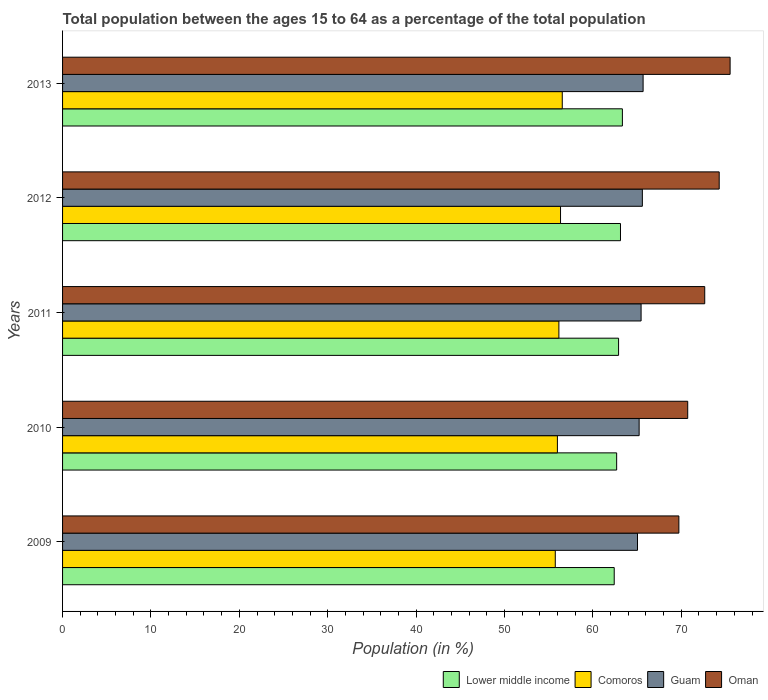How many groups of bars are there?
Your answer should be compact. 5. Are the number of bars per tick equal to the number of legend labels?
Your response must be concise. Yes. How many bars are there on the 3rd tick from the top?
Provide a succinct answer. 4. What is the label of the 1st group of bars from the top?
Provide a succinct answer. 2013. In how many cases, is the number of bars for a given year not equal to the number of legend labels?
Offer a terse response. 0. What is the percentage of the population ages 15 to 64 in Comoros in 2010?
Your answer should be very brief. 55.98. Across all years, what is the maximum percentage of the population ages 15 to 64 in Lower middle income?
Your answer should be compact. 63.34. Across all years, what is the minimum percentage of the population ages 15 to 64 in Lower middle income?
Ensure brevity in your answer.  62.41. In which year was the percentage of the population ages 15 to 64 in Comoros maximum?
Your answer should be compact. 2013. In which year was the percentage of the population ages 15 to 64 in Guam minimum?
Give a very brief answer. 2009. What is the total percentage of the population ages 15 to 64 in Comoros in the graph?
Offer a terse response. 280.75. What is the difference between the percentage of the population ages 15 to 64 in Oman in 2011 and that in 2013?
Your response must be concise. -2.87. What is the difference between the percentage of the population ages 15 to 64 in Guam in 2009 and the percentage of the population ages 15 to 64 in Comoros in 2012?
Give a very brief answer. 8.71. What is the average percentage of the population ages 15 to 64 in Guam per year?
Your answer should be very brief. 65.4. In the year 2011, what is the difference between the percentage of the population ages 15 to 64 in Comoros and percentage of the population ages 15 to 64 in Oman?
Make the answer very short. -16.5. In how many years, is the percentage of the population ages 15 to 64 in Comoros greater than 76 ?
Keep it short and to the point. 0. What is the ratio of the percentage of the population ages 15 to 64 in Oman in 2009 to that in 2013?
Your answer should be very brief. 0.92. Is the percentage of the population ages 15 to 64 in Guam in 2011 less than that in 2012?
Your answer should be very brief. Yes. Is the difference between the percentage of the population ages 15 to 64 in Comoros in 2010 and 2011 greater than the difference between the percentage of the population ages 15 to 64 in Oman in 2010 and 2011?
Make the answer very short. Yes. What is the difference between the highest and the second highest percentage of the population ages 15 to 64 in Guam?
Offer a terse response. 0.08. What is the difference between the highest and the lowest percentage of the population ages 15 to 64 in Oman?
Keep it short and to the point. 5.8. In how many years, is the percentage of the population ages 15 to 64 in Comoros greater than the average percentage of the population ages 15 to 64 in Comoros taken over all years?
Your answer should be compact. 3. Is it the case that in every year, the sum of the percentage of the population ages 15 to 64 in Comoros and percentage of the population ages 15 to 64 in Lower middle income is greater than the sum of percentage of the population ages 15 to 64 in Oman and percentage of the population ages 15 to 64 in Guam?
Your response must be concise. No. What does the 4th bar from the top in 2010 represents?
Your answer should be compact. Lower middle income. What does the 3rd bar from the bottom in 2010 represents?
Keep it short and to the point. Guam. Are the values on the major ticks of X-axis written in scientific E-notation?
Your response must be concise. No. Does the graph contain any zero values?
Your answer should be very brief. No. Where does the legend appear in the graph?
Your answer should be very brief. Bottom right. How are the legend labels stacked?
Offer a very short reply. Horizontal. What is the title of the graph?
Make the answer very short. Total population between the ages 15 to 64 as a percentage of the total population. What is the label or title of the Y-axis?
Provide a short and direct response. Years. What is the Population (in %) of Lower middle income in 2009?
Your answer should be compact. 62.41. What is the Population (in %) in Comoros in 2009?
Provide a short and direct response. 55.74. What is the Population (in %) in Guam in 2009?
Your answer should be compact. 65.05. What is the Population (in %) in Oman in 2009?
Provide a short and direct response. 69.73. What is the Population (in %) in Lower middle income in 2010?
Provide a short and direct response. 62.69. What is the Population (in %) of Comoros in 2010?
Ensure brevity in your answer.  55.98. What is the Population (in %) in Guam in 2010?
Provide a succinct answer. 65.23. What is the Population (in %) of Oman in 2010?
Ensure brevity in your answer.  70.73. What is the Population (in %) in Lower middle income in 2011?
Keep it short and to the point. 62.9. What is the Population (in %) of Comoros in 2011?
Offer a very short reply. 56.15. What is the Population (in %) of Guam in 2011?
Make the answer very short. 65.45. What is the Population (in %) in Oman in 2011?
Offer a terse response. 72.65. What is the Population (in %) of Lower middle income in 2012?
Provide a short and direct response. 63.12. What is the Population (in %) of Comoros in 2012?
Provide a succinct answer. 56.34. What is the Population (in %) in Guam in 2012?
Offer a very short reply. 65.6. What is the Population (in %) of Oman in 2012?
Provide a succinct answer. 74.29. What is the Population (in %) in Lower middle income in 2013?
Give a very brief answer. 63.34. What is the Population (in %) of Comoros in 2013?
Provide a short and direct response. 56.53. What is the Population (in %) in Guam in 2013?
Give a very brief answer. 65.68. What is the Population (in %) of Oman in 2013?
Make the answer very short. 75.52. Across all years, what is the maximum Population (in %) of Lower middle income?
Provide a succinct answer. 63.34. Across all years, what is the maximum Population (in %) in Comoros?
Ensure brevity in your answer.  56.53. Across all years, what is the maximum Population (in %) in Guam?
Give a very brief answer. 65.68. Across all years, what is the maximum Population (in %) in Oman?
Give a very brief answer. 75.52. Across all years, what is the minimum Population (in %) of Lower middle income?
Offer a terse response. 62.41. Across all years, what is the minimum Population (in %) in Comoros?
Keep it short and to the point. 55.74. Across all years, what is the minimum Population (in %) of Guam?
Offer a terse response. 65.05. Across all years, what is the minimum Population (in %) of Oman?
Offer a very short reply. 69.73. What is the total Population (in %) of Lower middle income in the graph?
Offer a very short reply. 314.46. What is the total Population (in %) in Comoros in the graph?
Your answer should be compact. 280.75. What is the total Population (in %) in Guam in the graph?
Your answer should be very brief. 327.01. What is the total Population (in %) of Oman in the graph?
Your answer should be compact. 362.92. What is the difference between the Population (in %) in Lower middle income in 2009 and that in 2010?
Your response must be concise. -0.28. What is the difference between the Population (in %) in Comoros in 2009 and that in 2010?
Offer a terse response. -0.24. What is the difference between the Population (in %) of Guam in 2009 and that in 2010?
Ensure brevity in your answer.  -0.19. What is the difference between the Population (in %) of Oman in 2009 and that in 2010?
Your response must be concise. -1. What is the difference between the Population (in %) in Lower middle income in 2009 and that in 2011?
Offer a very short reply. -0.49. What is the difference between the Population (in %) of Comoros in 2009 and that in 2011?
Ensure brevity in your answer.  -0.41. What is the difference between the Population (in %) of Guam in 2009 and that in 2011?
Make the answer very short. -0.41. What is the difference between the Population (in %) in Oman in 2009 and that in 2011?
Ensure brevity in your answer.  -2.93. What is the difference between the Population (in %) of Lower middle income in 2009 and that in 2012?
Make the answer very short. -0.71. What is the difference between the Population (in %) in Comoros in 2009 and that in 2012?
Your answer should be compact. -0.59. What is the difference between the Population (in %) in Guam in 2009 and that in 2012?
Your response must be concise. -0.55. What is the difference between the Population (in %) in Oman in 2009 and that in 2012?
Your answer should be very brief. -4.56. What is the difference between the Population (in %) of Lower middle income in 2009 and that in 2013?
Make the answer very short. -0.92. What is the difference between the Population (in %) in Comoros in 2009 and that in 2013?
Make the answer very short. -0.79. What is the difference between the Population (in %) of Guam in 2009 and that in 2013?
Ensure brevity in your answer.  -0.63. What is the difference between the Population (in %) of Oman in 2009 and that in 2013?
Your answer should be compact. -5.8. What is the difference between the Population (in %) in Lower middle income in 2010 and that in 2011?
Make the answer very short. -0.22. What is the difference between the Population (in %) in Comoros in 2010 and that in 2011?
Provide a short and direct response. -0.17. What is the difference between the Population (in %) in Guam in 2010 and that in 2011?
Offer a very short reply. -0.22. What is the difference between the Population (in %) of Oman in 2010 and that in 2011?
Ensure brevity in your answer.  -1.93. What is the difference between the Population (in %) in Lower middle income in 2010 and that in 2012?
Ensure brevity in your answer.  -0.43. What is the difference between the Population (in %) of Comoros in 2010 and that in 2012?
Offer a terse response. -0.35. What is the difference between the Population (in %) of Guam in 2010 and that in 2012?
Offer a very short reply. -0.36. What is the difference between the Population (in %) of Oman in 2010 and that in 2012?
Your answer should be compact. -3.56. What is the difference between the Population (in %) in Lower middle income in 2010 and that in 2013?
Keep it short and to the point. -0.65. What is the difference between the Population (in %) in Comoros in 2010 and that in 2013?
Give a very brief answer. -0.55. What is the difference between the Population (in %) of Guam in 2010 and that in 2013?
Keep it short and to the point. -0.45. What is the difference between the Population (in %) of Oman in 2010 and that in 2013?
Your answer should be very brief. -4.8. What is the difference between the Population (in %) of Lower middle income in 2011 and that in 2012?
Keep it short and to the point. -0.22. What is the difference between the Population (in %) of Comoros in 2011 and that in 2012?
Offer a very short reply. -0.19. What is the difference between the Population (in %) of Guam in 2011 and that in 2012?
Make the answer very short. -0.14. What is the difference between the Population (in %) of Oman in 2011 and that in 2012?
Your response must be concise. -1.64. What is the difference between the Population (in %) in Lower middle income in 2011 and that in 2013?
Provide a succinct answer. -0.43. What is the difference between the Population (in %) of Comoros in 2011 and that in 2013?
Keep it short and to the point. -0.38. What is the difference between the Population (in %) in Guam in 2011 and that in 2013?
Provide a short and direct response. -0.23. What is the difference between the Population (in %) of Oman in 2011 and that in 2013?
Your answer should be compact. -2.87. What is the difference between the Population (in %) of Lower middle income in 2012 and that in 2013?
Give a very brief answer. -0.21. What is the difference between the Population (in %) in Comoros in 2012 and that in 2013?
Your answer should be very brief. -0.2. What is the difference between the Population (in %) in Guam in 2012 and that in 2013?
Your answer should be compact. -0.08. What is the difference between the Population (in %) of Oman in 2012 and that in 2013?
Offer a very short reply. -1.23. What is the difference between the Population (in %) in Lower middle income in 2009 and the Population (in %) in Comoros in 2010?
Offer a very short reply. 6.43. What is the difference between the Population (in %) of Lower middle income in 2009 and the Population (in %) of Guam in 2010?
Ensure brevity in your answer.  -2.82. What is the difference between the Population (in %) of Lower middle income in 2009 and the Population (in %) of Oman in 2010?
Provide a short and direct response. -8.31. What is the difference between the Population (in %) in Comoros in 2009 and the Population (in %) in Guam in 2010?
Provide a succinct answer. -9.49. What is the difference between the Population (in %) in Comoros in 2009 and the Population (in %) in Oman in 2010?
Your answer should be very brief. -14.98. What is the difference between the Population (in %) of Guam in 2009 and the Population (in %) of Oman in 2010?
Your response must be concise. -5.68. What is the difference between the Population (in %) in Lower middle income in 2009 and the Population (in %) in Comoros in 2011?
Make the answer very short. 6.26. What is the difference between the Population (in %) in Lower middle income in 2009 and the Population (in %) in Guam in 2011?
Provide a short and direct response. -3.04. What is the difference between the Population (in %) in Lower middle income in 2009 and the Population (in %) in Oman in 2011?
Provide a succinct answer. -10.24. What is the difference between the Population (in %) in Comoros in 2009 and the Population (in %) in Guam in 2011?
Your answer should be very brief. -9.71. What is the difference between the Population (in %) in Comoros in 2009 and the Population (in %) in Oman in 2011?
Make the answer very short. -16.91. What is the difference between the Population (in %) of Guam in 2009 and the Population (in %) of Oman in 2011?
Ensure brevity in your answer.  -7.61. What is the difference between the Population (in %) of Lower middle income in 2009 and the Population (in %) of Comoros in 2012?
Offer a terse response. 6.07. What is the difference between the Population (in %) in Lower middle income in 2009 and the Population (in %) in Guam in 2012?
Ensure brevity in your answer.  -3.18. What is the difference between the Population (in %) in Lower middle income in 2009 and the Population (in %) in Oman in 2012?
Keep it short and to the point. -11.88. What is the difference between the Population (in %) of Comoros in 2009 and the Population (in %) of Guam in 2012?
Provide a succinct answer. -9.85. What is the difference between the Population (in %) of Comoros in 2009 and the Population (in %) of Oman in 2012?
Your response must be concise. -18.54. What is the difference between the Population (in %) in Guam in 2009 and the Population (in %) in Oman in 2012?
Your response must be concise. -9.24. What is the difference between the Population (in %) in Lower middle income in 2009 and the Population (in %) in Comoros in 2013?
Your answer should be very brief. 5.88. What is the difference between the Population (in %) in Lower middle income in 2009 and the Population (in %) in Guam in 2013?
Make the answer very short. -3.27. What is the difference between the Population (in %) of Lower middle income in 2009 and the Population (in %) of Oman in 2013?
Your answer should be very brief. -13.11. What is the difference between the Population (in %) of Comoros in 2009 and the Population (in %) of Guam in 2013?
Your answer should be very brief. -9.94. What is the difference between the Population (in %) of Comoros in 2009 and the Population (in %) of Oman in 2013?
Offer a terse response. -19.78. What is the difference between the Population (in %) of Guam in 2009 and the Population (in %) of Oman in 2013?
Give a very brief answer. -10.48. What is the difference between the Population (in %) in Lower middle income in 2010 and the Population (in %) in Comoros in 2011?
Keep it short and to the point. 6.54. What is the difference between the Population (in %) of Lower middle income in 2010 and the Population (in %) of Guam in 2011?
Give a very brief answer. -2.76. What is the difference between the Population (in %) of Lower middle income in 2010 and the Population (in %) of Oman in 2011?
Give a very brief answer. -9.96. What is the difference between the Population (in %) in Comoros in 2010 and the Population (in %) in Guam in 2011?
Your answer should be compact. -9.47. What is the difference between the Population (in %) of Comoros in 2010 and the Population (in %) of Oman in 2011?
Your answer should be compact. -16.67. What is the difference between the Population (in %) of Guam in 2010 and the Population (in %) of Oman in 2011?
Offer a terse response. -7.42. What is the difference between the Population (in %) of Lower middle income in 2010 and the Population (in %) of Comoros in 2012?
Your response must be concise. 6.35. What is the difference between the Population (in %) in Lower middle income in 2010 and the Population (in %) in Guam in 2012?
Your answer should be very brief. -2.91. What is the difference between the Population (in %) of Lower middle income in 2010 and the Population (in %) of Oman in 2012?
Provide a succinct answer. -11.6. What is the difference between the Population (in %) in Comoros in 2010 and the Population (in %) in Guam in 2012?
Offer a very short reply. -9.61. What is the difference between the Population (in %) of Comoros in 2010 and the Population (in %) of Oman in 2012?
Make the answer very short. -18.31. What is the difference between the Population (in %) in Guam in 2010 and the Population (in %) in Oman in 2012?
Your answer should be compact. -9.06. What is the difference between the Population (in %) of Lower middle income in 2010 and the Population (in %) of Comoros in 2013?
Offer a terse response. 6.15. What is the difference between the Population (in %) in Lower middle income in 2010 and the Population (in %) in Guam in 2013?
Your answer should be very brief. -2.99. What is the difference between the Population (in %) of Lower middle income in 2010 and the Population (in %) of Oman in 2013?
Provide a succinct answer. -12.84. What is the difference between the Population (in %) in Comoros in 2010 and the Population (in %) in Guam in 2013?
Keep it short and to the point. -9.7. What is the difference between the Population (in %) in Comoros in 2010 and the Population (in %) in Oman in 2013?
Offer a terse response. -19.54. What is the difference between the Population (in %) of Guam in 2010 and the Population (in %) of Oman in 2013?
Your response must be concise. -10.29. What is the difference between the Population (in %) of Lower middle income in 2011 and the Population (in %) of Comoros in 2012?
Make the answer very short. 6.57. What is the difference between the Population (in %) of Lower middle income in 2011 and the Population (in %) of Guam in 2012?
Offer a very short reply. -2.69. What is the difference between the Population (in %) in Lower middle income in 2011 and the Population (in %) in Oman in 2012?
Offer a terse response. -11.38. What is the difference between the Population (in %) of Comoros in 2011 and the Population (in %) of Guam in 2012?
Offer a very short reply. -9.44. What is the difference between the Population (in %) in Comoros in 2011 and the Population (in %) in Oman in 2012?
Offer a very short reply. -18.14. What is the difference between the Population (in %) of Guam in 2011 and the Population (in %) of Oman in 2012?
Provide a succinct answer. -8.84. What is the difference between the Population (in %) in Lower middle income in 2011 and the Population (in %) in Comoros in 2013?
Your response must be concise. 6.37. What is the difference between the Population (in %) in Lower middle income in 2011 and the Population (in %) in Guam in 2013?
Make the answer very short. -2.78. What is the difference between the Population (in %) in Lower middle income in 2011 and the Population (in %) in Oman in 2013?
Your answer should be very brief. -12.62. What is the difference between the Population (in %) in Comoros in 2011 and the Population (in %) in Guam in 2013?
Offer a terse response. -9.53. What is the difference between the Population (in %) of Comoros in 2011 and the Population (in %) of Oman in 2013?
Offer a terse response. -19.37. What is the difference between the Population (in %) of Guam in 2011 and the Population (in %) of Oman in 2013?
Provide a short and direct response. -10.07. What is the difference between the Population (in %) of Lower middle income in 2012 and the Population (in %) of Comoros in 2013?
Offer a very short reply. 6.59. What is the difference between the Population (in %) in Lower middle income in 2012 and the Population (in %) in Guam in 2013?
Keep it short and to the point. -2.56. What is the difference between the Population (in %) in Lower middle income in 2012 and the Population (in %) in Oman in 2013?
Ensure brevity in your answer.  -12.4. What is the difference between the Population (in %) in Comoros in 2012 and the Population (in %) in Guam in 2013?
Make the answer very short. -9.34. What is the difference between the Population (in %) of Comoros in 2012 and the Population (in %) of Oman in 2013?
Make the answer very short. -19.19. What is the difference between the Population (in %) in Guam in 2012 and the Population (in %) in Oman in 2013?
Keep it short and to the point. -9.93. What is the average Population (in %) in Lower middle income per year?
Your response must be concise. 62.89. What is the average Population (in %) of Comoros per year?
Ensure brevity in your answer.  56.15. What is the average Population (in %) of Guam per year?
Offer a very short reply. 65.4. What is the average Population (in %) in Oman per year?
Provide a short and direct response. 72.58. In the year 2009, what is the difference between the Population (in %) of Lower middle income and Population (in %) of Comoros?
Your answer should be very brief. 6.67. In the year 2009, what is the difference between the Population (in %) of Lower middle income and Population (in %) of Guam?
Offer a very short reply. -2.63. In the year 2009, what is the difference between the Population (in %) in Lower middle income and Population (in %) in Oman?
Ensure brevity in your answer.  -7.31. In the year 2009, what is the difference between the Population (in %) of Comoros and Population (in %) of Guam?
Provide a short and direct response. -9.3. In the year 2009, what is the difference between the Population (in %) of Comoros and Population (in %) of Oman?
Keep it short and to the point. -13.98. In the year 2009, what is the difference between the Population (in %) in Guam and Population (in %) in Oman?
Keep it short and to the point. -4.68. In the year 2010, what is the difference between the Population (in %) in Lower middle income and Population (in %) in Comoros?
Ensure brevity in your answer.  6.7. In the year 2010, what is the difference between the Population (in %) of Lower middle income and Population (in %) of Guam?
Give a very brief answer. -2.54. In the year 2010, what is the difference between the Population (in %) of Lower middle income and Population (in %) of Oman?
Your response must be concise. -8.04. In the year 2010, what is the difference between the Population (in %) in Comoros and Population (in %) in Guam?
Make the answer very short. -9.25. In the year 2010, what is the difference between the Population (in %) in Comoros and Population (in %) in Oman?
Your answer should be compact. -14.74. In the year 2010, what is the difference between the Population (in %) in Guam and Population (in %) in Oman?
Make the answer very short. -5.5. In the year 2011, what is the difference between the Population (in %) of Lower middle income and Population (in %) of Comoros?
Offer a terse response. 6.75. In the year 2011, what is the difference between the Population (in %) of Lower middle income and Population (in %) of Guam?
Keep it short and to the point. -2.55. In the year 2011, what is the difference between the Population (in %) of Lower middle income and Population (in %) of Oman?
Keep it short and to the point. -9.75. In the year 2011, what is the difference between the Population (in %) in Comoros and Population (in %) in Guam?
Provide a short and direct response. -9.3. In the year 2011, what is the difference between the Population (in %) in Comoros and Population (in %) in Oman?
Ensure brevity in your answer.  -16.5. In the year 2011, what is the difference between the Population (in %) of Guam and Population (in %) of Oman?
Make the answer very short. -7.2. In the year 2012, what is the difference between the Population (in %) in Lower middle income and Population (in %) in Comoros?
Your response must be concise. 6.78. In the year 2012, what is the difference between the Population (in %) of Lower middle income and Population (in %) of Guam?
Provide a short and direct response. -2.47. In the year 2012, what is the difference between the Population (in %) of Lower middle income and Population (in %) of Oman?
Your answer should be compact. -11.17. In the year 2012, what is the difference between the Population (in %) of Comoros and Population (in %) of Guam?
Your response must be concise. -9.26. In the year 2012, what is the difference between the Population (in %) in Comoros and Population (in %) in Oman?
Provide a short and direct response. -17.95. In the year 2012, what is the difference between the Population (in %) of Guam and Population (in %) of Oman?
Keep it short and to the point. -8.69. In the year 2013, what is the difference between the Population (in %) in Lower middle income and Population (in %) in Comoros?
Offer a very short reply. 6.8. In the year 2013, what is the difference between the Population (in %) of Lower middle income and Population (in %) of Guam?
Your answer should be very brief. -2.35. In the year 2013, what is the difference between the Population (in %) in Lower middle income and Population (in %) in Oman?
Give a very brief answer. -12.19. In the year 2013, what is the difference between the Population (in %) of Comoros and Population (in %) of Guam?
Offer a very short reply. -9.15. In the year 2013, what is the difference between the Population (in %) of Comoros and Population (in %) of Oman?
Ensure brevity in your answer.  -18.99. In the year 2013, what is the difference between the Population (in %) of Guam and Population (in %) of Oman?
Offer a terse response. -9.84. What is the ratio of the Population (in %) of Lower middle income in 2009 to that in 2010?
Your response must be concise. 1. What is the ratio of the Population (in %) in Oman in 2009 to that in 2010?
Provide a succinct answer. 0.99. What is the ratio of the Population (in %) in Comoros in 2009 to that in 2011?
Provide a succinct answer. 0.99. What is the ratio of the Population (in %) in Oman in 2009 to that in 2011?
Your answer should be compact. 0.96. What is the ratio of the Population (in %) of Lower middle income in 2009 to that in 2012?
Offer a terse response. 0.99. What is the ratio of the Population (in %) in Comoros in 2009 to that in 2012?
Your response must be concise. 0.99. What is the ratio of the Population (in %) of Oman in 2009 to that in 2012?
Keep it short and to the point. 0.94. What is the ratio of the Population (in %) of Lower middle income in 2009 to that in 2013?
Give a very brief answer. 0.99. What is the ratio of the Population (in %) of Guam in 2009 to that in 2013?
Offer a very short reply. 0.99. What is the ratio of the Population (in %) of Oman in 2009 to that in 2013?
Offer a terse response. 0.92. What is the ratio of the Population (in %) of Comoros in 2010 to that in 2011?
Give a very brief answer. 1. What is the ratio of the Population (in %) of Guam in 2010 to that in 2011?
Give a very brief answer. 1. What is the ratio of the Population (in %) in Oman in 2010 to that in 2011?
Provide a short and direct response. 0.97. What is the ratio of the Population (in %) of Lower middle income in 2010 to that in 2012?
Your response must be concise. 0.99. What is the ratio of the Population (in %) in Oman in 2010 to that in 2012?
Your answer should be very brief. 0.95. What is the ratio of the Population (in %) of Lower middle income in 2010 to that in 2013?
Offer a very short reply. 0.99. What is the ratio of the Population (in %) of Comoros in 2010 to that in 2013?
Make the answer very short. 0.99. What is the ratio of the Population (in %) of Guam in 2010 to that in 2013?
Ensure brevity in your answer.  0.99. What is the ratio of the Population (in %) of Oman in 2010 to that in 2013?
Your answer should be very brief. 0.94. What is the ratio of the Population (in %) of Oman in 2011 to that in 2012?
Offer a terse response. 0.98. What is the ratio of the Population (in %) of Guam in 2012 to that in 2013?
Offer a very short reply. 1. What is the ratio of the Population (in %) in Oman in 2012 to that in 2013?
Your response must be concise. 0.98. What is the difference between the highest and the second highest Population (in %) of Lower middle income?
Ensure brevity in your answer.  0.21. What is the difference between the highest and the second highest Population (in %) in Comoros?
Provide a short and direct response. 0.2. What is the difference between the highest and the second highest Population (in %) of Guam?
Make the answer very short. 0.08. What is the difference between the highest and the second highest Population (in %) in Oman?
Ensure brevity in your answer.  1.23. What is the difference between the highest and the lowest Population (in %) in Lower middle income?
Make the answer very short. 0.92. What is the difference between the highest and the lowest Population (in %) of Comoros?
Keep it short and to the point. 0.79. What is the difference between the highest and the lowest Population (in %) of Guam?
Provide a short and direct response. 0.63. What is the difference between the highest and the lowest Population (in %) of Oman?
Your answer should be very brief. 5.8. 